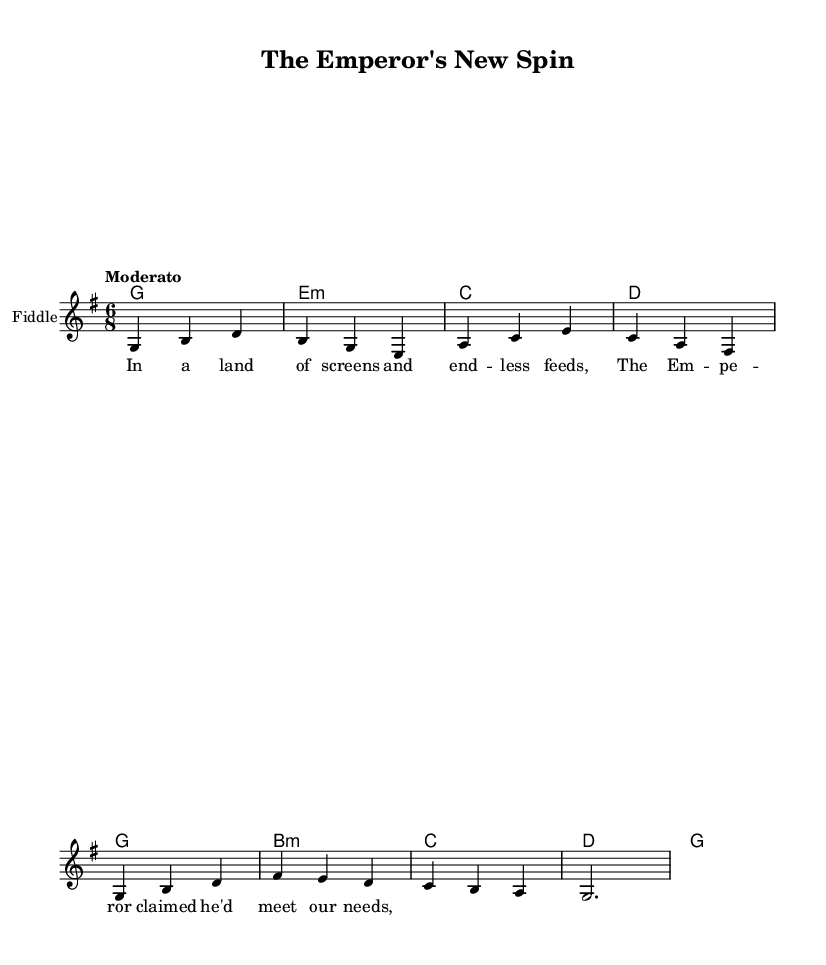What is the time signature of this music? The time signature is indicated at the beginning of the score. In this case, it shows 6/8, which indicates there are six eighth notes per measure.
Answer: 6/8 What key is this piece composed in? The key signature is displayed at the beginning of the music and indicates the tonality. Here, it is G major, which has one sharp (F#).
Answer: G major What is the tempo marking for this piece? The tempo marking is provided in the score, which instructs the performer on the speed of the piece. In this example, it is marked "Moderato," suggesting a moderate tempo.
Answer: Moderato What instrument is primarily indicated for this score? The instrument name is stated at the beginning of the staff, and it reflects what instrument should perform the piece. In this case, it states "Fiddle."
Answer: Fiddle How many measures are present in the melody section? To find the number of measures, count the grouped sets of notes in the melody line. Each group separated by a bar line indicates a new measure. There are eight measures in total in the melody section.
Answer: 8 What is the first lyric line of the verse? The lyrics are provided under the melody, and the first line is the initial text that corresponds with the first melodic phrase. It reads "In a land of screens and end--less feeds."
Answer: In a land of screens and end -- less feeds What type of folk theme does this composition suggest? The lyrics and title point toward a reinterpretation of a traditional narrative that critiques modern political issues. The use of "The Emperor" suggests a theme of authority and societal critique.
Answer: Sociopolitical critique 